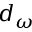Convert formula to latex. <formula><loc_0><loc_0><loc_500><loc_500>d _ { \omega }</formula> 